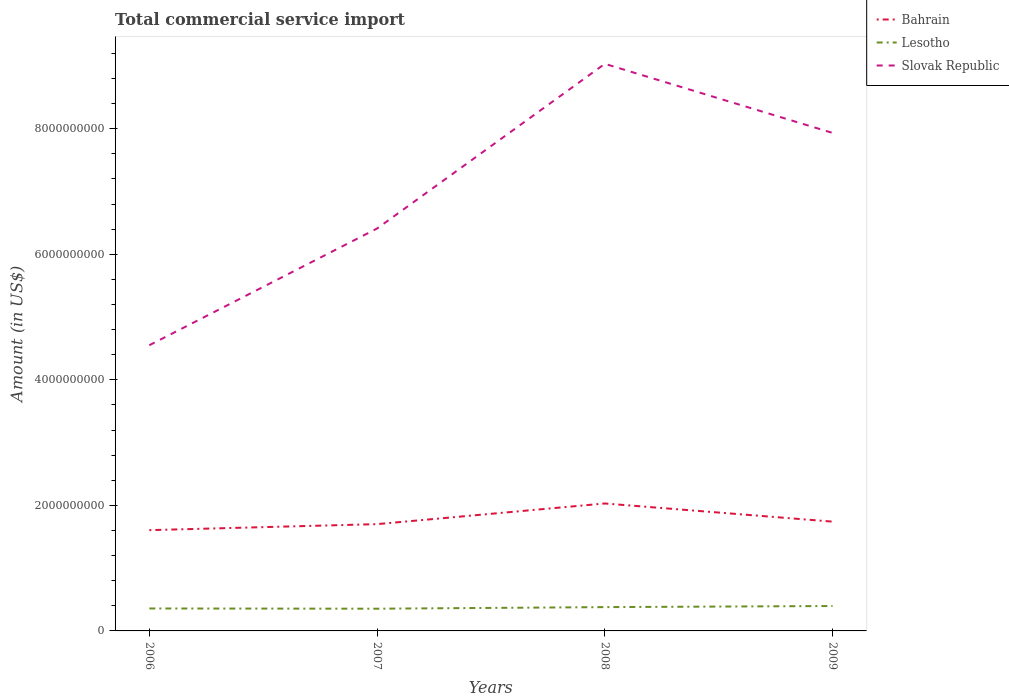How many different coloured lines are there?
Keep it short and to the point. 3. Is the number of lines equal to the number of legend labels?
Give a very brief answer. Yes. Across all years, what is the maximum total commercial service import in Slovak Republic?
Provide a short and direct response. 4.55e+09. What is the total total commercial service import in Slovak Republic in the graph?
Your answer should be very brief. -3.38e+09. What is the difference between the highest and the second highest total commercial service import in Slovak Republic?
Give a very brief answer. 4.48e+09. How many lines are there?
Offer a very short reply. 3. Are the values on the major ticks of Y-axis written in scientific E-notation?
Provide a short and direct response. No. Does the graph contain any zero values?
Keep it short and to the point. No. Does the graph contain grids?
Ensure brevity in your answer.  No. Where does the legend appear in the graph?
Offer a very short reply. Top right. What is the title of the graph?
Ensure brevity in your answer.  Total commercial service import. Does "Central African Republic" appear as one of the legend labels in the graph?
Give a very brief answer. No. What is the label or title of the X-axis?
Offer a terse response. Years. What is the Amount (in US$) in Bahrain in 2006?
Your response must be concise. 1.61e+09. What is the Amount (in US$) in Lesotho in 2006?
Make the answer very short. 3.58e+08. What is the Amount (in US$) of Slovak Republic in 2006?
Offer a terse response. 4.55e+09. What is the Amount (in US$) of Bahrain in 2007?
Your answer should be very brief. 1.70e+09. What is the Amount (in US$) in Lesotho in 2007?
Ensure brevity in your answer.  3.54e+08. What is the Amount (in US$) in Slovak Republic in 2007?
Your response must be concise. 6.41e+09. What is the Amount (in US$) in Bahrain in 2008?
Your answer should be compact. 2.03e+09. What is the Amount (in US$) of Lesotho in 2008?
Your answer should be compact. 3.79e+08. What is the Amount (in US$) of Slovak Republic in 2008?
Give a very brief answer. 9.03e+09. What is the Amount (in US$) of Bahrain in 2009?
Provide a succinct answer. 1.74e+09. What is the Amount (in US$) of Lesotho in 2009?
Your response must be concise. 3.97e+08. What is the Amount (in US$) of Slovak Republic in 2009?
Provide a short and direct response. 7.93e+09. Across all years, what is the maximum Amount (in US$) in Bahrain?
Your answer should be compact. 2.03e+09. Across all years, what is the maximum Amount (in US$) in Lesotho?
Give a very brief answer. 3.97e+08. Across all years, what is the maximum Amount (in US$) in Slovak Republic?
Keep it short and to the point. 9.03e+09. Across all years, what is the minimum Amount (in US$) of Bahrain?
Offer a terse response. 1.61e+09. Across all years, what is the minimum Amount (in US$) in Lesotho?
Your answer should be compact. 3.54e+08. Across all years, what is the minimum Amount (in US$) of Slovak Republic?
Keep it short and to the point. 4.55e+09. What is the total Amount (in US$) of Bahrain in the graph?
Keep it short and to the point. 7.08e+09. What is the total Amount (in US$) in Lesotho in the graph?
Keep it short and to the point. 1.49e+09. What is the total Amount (in US$) of Slovak Republic in the graph?
Give a very brief answer. 2.79e+1. What is the difference between the Amount (in US$) of Bahrain in 2006 and that in 2007?
Your answer should be compact. -9.57e+07. What is the difference between the Amount (in US$) of Lesotho in 2006 and that in 2007?
Provide a short and direct response. 3.63e+06. What is the difference between the Amount (in US$) in Slovak Republic in 2006 and that in 2007?
Your answer should be very brief. -1.86e+09. What is the difference between the Amount (in US$) of Bahrain in 2006 and that in 2008?
Give a very brief answer. -4.25e+08. What is the difference between the Amount (in US$) of Lesotho in 2006 and that in 2008?
Your answer should be compact. -2.15e+07. What is the difference between the Amount (in US$) of Slovak Republic in 2006 and that in 2008?
Ensure brevity in your answer.  -4.48e+09. What is the difference between the Amount (in US$) of Bahrain in 2006 and that in 2009?
Give a very brief answer. -1.36e+08. What is the difference between the Amount (in US$) in Lesotho in 2006 and that in 2009?
Ensure brevity in your answer.  -3.92e+07. What is the difference between the Amount (in US$) in Slovak Republic in 2006 and that in 2009?
Your answer should be very brief. -3.38e+09. What is the difference between the Amount (in US$) of Bahrain in 2007 and that in 2008?
Make the answer very short. -3.29e+08. What is the difference between the Amount (in US$) in Lesotho in 2007 and that in 2008?
Your answer should be very brief. -2.52e+07. What is the difference between the Amount (in US$) of Slovak Republic in 2007 and that in 2008?
Your answer should be compact. -2.62e+09. What is the difference between the Amount (in US$) in Bahrain in 2007 and that in 2009?
Your response must be concise. -4.00e+07. What is the difference between the Amount (in US$) of Lesotho in 2007 and that in 2009?
Your answer should be very brief. -4.28e+07. What is the difference between the Amount (in US$) in Slovak Republic in 2007 and that in 2009?
Keep it short and to the point. -1.52e+09. What is the difference between the Amount (in US$) of Bahrain in 2008 and that in 2009?
Offer a terse response. 2.89e+08. What is the difference between the Amount (in US$) of Lesotho in 2008 and that in 2009?
Make the answer very short. -1.77e+07. What is the difference between the Amount (in US$) in Slovak Republic in 2008 and that in 2009?
Keep it short and to the point. 1.10e+09. What is the difference between the Amount (in US$) of Bahrain in 2006 and the Amount (in US$) of Lesotho in 2007?
Provide a short and direct response. 1.25e+09. What is the difference between the Amount (in US$) in Bahrain in 2006 and the Amount (in US$) in Slovak Republic in 2007?
Provide a short and direct response. -4.80e+09. What is the difference between the Amount (in US$) of Lesotho in 2006 and the Amount (in US$) of Slovak Republic in 2007?
Offer a terse response. -6.05e+09. What is the difference between the Amount (in US$) of Bahrain in 2006 and the Amount (in US$) of Lesotho in 2008?
Provide a short and direct response. 1.23e+09. What is the difference between the Amount (in US$) of Bahrain in 2006 and the Amount (in US$) of Slovak Republic in 2008?
Keep it short and to the point. -7.43e+09. What is the difference between the Amount (in US$) of Lesotho in 2006 and the Amount (in US$) of Slovak Republic in 2008?
Make the answer very short. -8.68e+09. What is the difference between the Amount (in US$) of Bahrain in 2006 and the Amount (in US$) of Lesotho in 2009?
Provide a succinct answer. 1.21e+09. What is the difference between the Amount (in US$) of Bahrain in 2006 and the Amount (in US$) of Slovak Republic in 2009?
Provide a succinct answer. -6.33e+09. What is the difference between the Amount (in US$) in Lesotho in 2006 and the Amount (in US$) in Slovak Republic in 2009?
Make the answer very short. -7.58e+09. What is the difference between the Amount (in US$) in Bahrain in 2007 and the Amount (in US$) in Lesotho in 2008?
Make the answer very short. 1.32e+09. What is the difference between the Amount (in US$) of Bahrain in 2007 and the Amount (in US$) of Slovak Republic in 2008?
Provide a short and direct response. -7.33e+09. What is the difference between the Amount (in US$) in Lesotho in 2007 and the Amount (in US$) in Slovak Republic in 2008?
Provide a short and direct response. -8.68e+09. What is the difference between the Amount (in US$) in Bahrain in 2007 and the Amount (in US$) in Lesotho in 2009?
Your response must be concise. 1.30e+09. What is the difference between the Amount (in US$) in Bahrain in 2007 and the Amount (in US$) in Slovak Republic in 2009?
Your answer should be compact. -6.23e+09. What is the difference between the Amount (in US$) in Lesotho in 2007 and the Amount (in US$) in Slovak Republic in 2009?
Offer a very short reply. -7.58e+09. What is the difference between the Amount (in US$) in Bahrain in 2008 and the Amount (in US$) in Lesotho in 2009?
Offer a very short reply. 1.63e+09. What is the difference between the Amount (in US$) in Bahrain in 2008 and the Amount (in US$) in Slovak Republic in 2009?
Your answer should be very brief. -5.90e+09. What is the difference between the Amount (in US$) in Lesotho in 2008 and the Amount (in US$) in Slovak Republic in 2009?
Keep it short and to the point. -7.55e+09. What is the average Amount (in US$) of Bahrain per year?
Make the answer very short. 1.77e+09. What is the average Amount (in US$) in Lesotho per year?
Ensure brevity in your answer.  3.72e+08. What is the average Amount (in US$) in Slovak Republic per year?
Your answer should be compact. 6.98e+09. In the year 2006, what is the difference between the Amount (in US$) of Bahrain and Amount (in US$) of Lesotho?
Make the answer very short. 1.25e+09. In the year 2006, what is the difference between the Amount (in US$) in Bahrain and Amount (in US$) in Slovak Republic?
Provide a short and direct response. -2.95e+09. In the year 2006, what is the difference between the Amount (in US$) of Lesotho and Amount (in US$) of Slovak Republic?
Ensure brevity in your answer.  -4.19e+09. In the year 2007, what is the difference between the Amount (in US$) of Bahrain and Amount (in US$) of Lesotho?
Give a very brief answer. 1.35e+09. In the year 2007, what is the difference between the Amount (in US$) of Bahrain and Amount (in US$) of Slovak Republic?
Make the answer very short. -4.71e+09. In the year 2007, what is the difference between the Amount (in US$) in Lesotho and Amount (in US$) in Slovak Republic?
Make the answer very short. -6.06e+09. In the year 2008, what is the difference between the Amount (in US$) of Bahrain and Amount (in US$) of Lesotho?
Your answer should be very brief. 1.65e+09. In the year 2008, what is the difference between the Amount (in US$) in Bahrain and Amount (in US$) in Slovak Republic?
Offer a terse response. -7.00e+09. In the year 2008, what is the difference between the Amount (in US$) of Lesotho and Amount (in US$) of Slovak Republic?
Your answer should be very brief. -8.65e+09. In the year 2009, what is the difference between the Amount (in US$) in Bahrain and Amount (in US$) in Lesotho?
Provide a succinct answer. 1.34e+09. In the year 2009, what is the difference between the Amount (in US$) of Bahrain and Amount (in US$) of Slovak Republic?
Provide a short and direct response. -6.19e+09. In the year 2009, what is the difference between the Amount (in US$) in Lesotho and Amount (in US$) in Slovak Republic?
Provide a succinct answer. -7.54e+09. What is the ratio of the Amount (in US$) in Bahrain in 2006 to that in 2007?
Ensure brevity in your answer.  0.94. What is the ratio of the Amount (in US$) of Lesotho in 2006 to that in 2007?
Provide a short and direct response. 1.01. What is the ratio of the Amount (in US$) in Slovak Republic in 2006 to that in 2007?
Your answer should be compact. 0.71. What is the ratio of the Amount (in US$) of Bahrain in 2006 to that in 2008?
Make the answer very short. 0.79. What is the ratio of the Amount (in US$) in Lesotho in 2006 to that in 2008?
Offer a terse response. 0.94. What is the ratio of the Amount (in US$) of Slovak Republic in 2006 to that in 2008?
Give a very brief answer. 0.5. What is the ratio of the Amount (in US$) of Bahrain in 2006 to that in 2009?
Provide a succinct answer. 0.92. What is the ratio of the Amount (in US$) in Lesotho in 2006 to that in 2009?
Your answer should be very brief. 0.9. What is the ratio of the Amount (in US$) of Slovak Republic in 2006 to that in 2009?
Provide a succinct answer. 0.57. What is the ratio of the Amount (in US$) of Bahrain in 2007 to that in 2008?
Offer a terse response. 0.84. What is the ratio of the Amount (in US$) of Lesotho in 2007 to that in 2008?
Give a very brief answer. 0.93. What is the ratio of the Amount (in US$) in Slovak Republic in 2007 to that in 2008?
Give a very brief answer. 0.71. What is the ratio of the Amount (in US$) in Bahrain in 2007 to that in 2009?
Offer a very short reply. 0.98. What is the ratio of the Amount (in US$) of Lesotho in 2007 to that in 2009?
Make the answer very short. 0.89. What is the ratio of the Amount (in US$) in Slovak Republic in 2007 to that in 2009?
Your response must be concise. 0.81. What is the ratio of the Amount (in US$) of Bahrain in 2008 to that in 2009?
Provide a short and direct response. 1.17. What is the ratio of the Amount (in US$) of Lesotho in 2008 to that in 2009?
Provide a succinct answer. 0.96. What is the ratio of the Amount (in US$) in Slovak Republic in 2008 to that in 2009?
Make the answer very short. 1.14. What is the difference between the highest and the second highest Amount (in US$) in Bahrain?
Provide a succinct answer. 2.89e+08. What is the difference between the highest and the second highest Amount (in US$) of Lesotho?
Your response must be concise. 1.77e+07. What is the difference between the highest and the second highest Amount (in US$) of Slovak Republic?
Your answer should be very brief. 1.10e+09. What is the difference between the highest and the lowest Amount (in US$) in Bahrain?
Your answer should be very brief. 4.25e+08. What is the difference between the highest and the lowest Amount (in US$) of Lesotho?
Ensure brevity in your answer.  4.28e+07. What is the difference between the highest and the lowest Amount (in US$) in Slovak Republic?
Provide a short and direct response. 4.48e+09. 